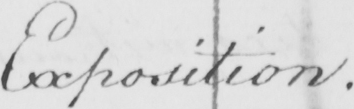Please provide the text content of this handwritten line. Exposition . 